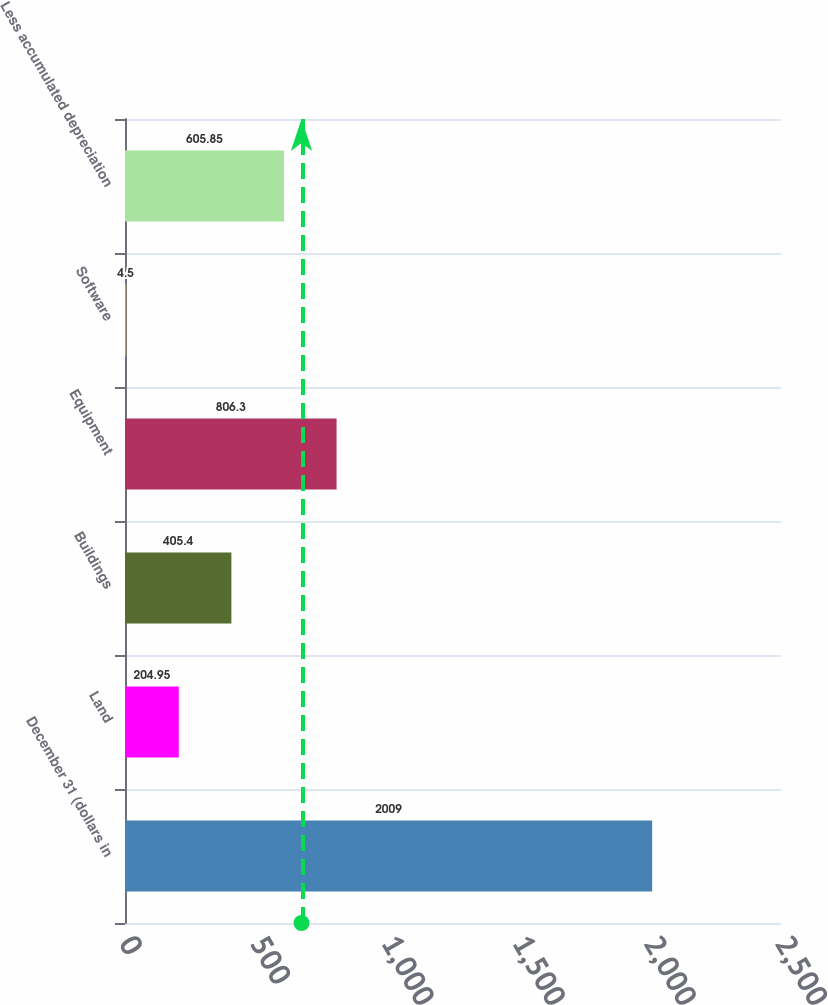Convert chart to OTSL. <chart><loc_0><loc_0><loc_500><loc_500><bar_chart><fcel>December 31 (dollars in<fcel>Land<fcel>Buildings<fcel>Equipment<fcel>Software<fcel>Less accumulated depreciation<nl><fcel>2009<fcel>204.95<fcel>405.4<fcel>806.3<fcel>4.5<fcel>605.85<nl></chart> 